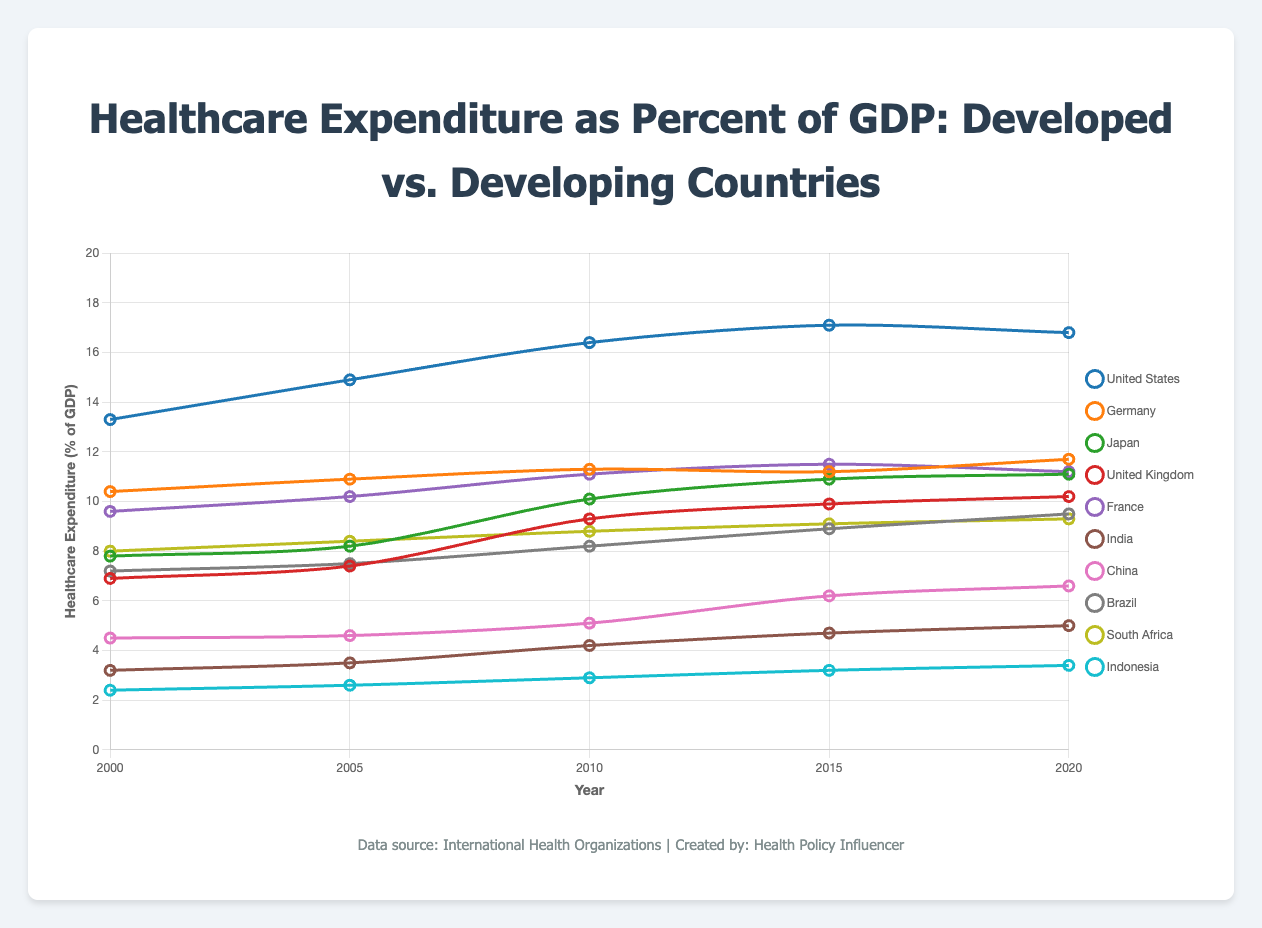What is the trend in healthcare expenditure as a percent of GDP for the United States from 2000 to 2020? To determine the trend, observe the data points for the United States over the given years: 13.3% in 2000, 14.9% in 2005, 16.4% in 2010, 17.1% in 2015, and 16.8% in 2020. The expenditures generally increase from 2000 to 2015, peaking at 17.1% in 2015, then slightly decrease to 16.8% in 2020.
Answer: Increasing trend with a peak in 2015 Which developing country has the highest healthcare expenditure as a percent of GDP in 2020? To answer this, compare the 2020 data for the developing countries: India (5.0%), China (6.6%), Brazil (9.5%), South Africa (9.3%), and Indonesia (3.4%). Brazil has the highest value at 9.5%.
Answer: Brazil Which developed country showed the greatest increase in healthcare expenditure as a percent of GDP between 2000 and 2020? Compute the increase for each developed country by subtracting the 2000 value from the 2020 value: United States (16.8 - 13.3 = 3.5), Germany (11.7 - 10.4 = 1.3), Japan (11.1 - 7.8 = 3.3), United Kingdom (10.2 - 6.9 = 3.3), France (11.2 - 9.6 = 1.6). The United States has the greatest increase of 3.5%.
Answer: United States Among developed countries, which country had the lowest healthcare expenditure as a percent of GDP in 2000? Review the 2000 data for developed countries: United States (13.3%), Germany (10.4%), Japan (7.8%), United Kingdom (6.9%), and France (9.6%). The United Kingdom had the lowest expenditure at 6.9%.
Answer: United Kingdom What is the average healthcare expenditure as a percent of GDP for India from 2000 to 2020? Sum the values for India over the years and divide by the number of years: (3.2 + 3.5 + 4.2 + 4.7 + 5.0) / 5 = 20.6 / 5 = 4.12%.
Answer: 4.12% Compare the healthcare expenditure trends of China and the United Kingdom between 2000 and 2020. Which country shows a steeper increase? Calculate the increase for each: China (6.6 - 4.5 = 2.1), United Kingdom (10.2 - 6.9 = 3.3). The United Kingdom shows a steeper increase from 6.9 to 10.2 (3.3) compared to China's (2.1).
Answer: United Kingdom What is the combined average healthcare expenditure for developed countries in 2020? Sum the 2020 values for developed countries and divide by the number of countries: (16.8 + 11.7 + 11.1 + 10.2 + 11.2) / 5 = 61 / 5 = 12.2%.
Answer: 12.2% What can be inferred about the healthcare expenditure trends in developing countries from 2000 to 2020? Observing the data for developing countries, all show an increasing trend over the years: India (3.2 to 5.0), China (4.5 to 6.6), Brazil (7.2 to 9.5), South Africa (8.0 to 9.3), and Indonesia (2.4 to 3.4). This indicates a general increase in healthcare expenditure as a percent of GDP across these nations.
Answer: Increasing trend 